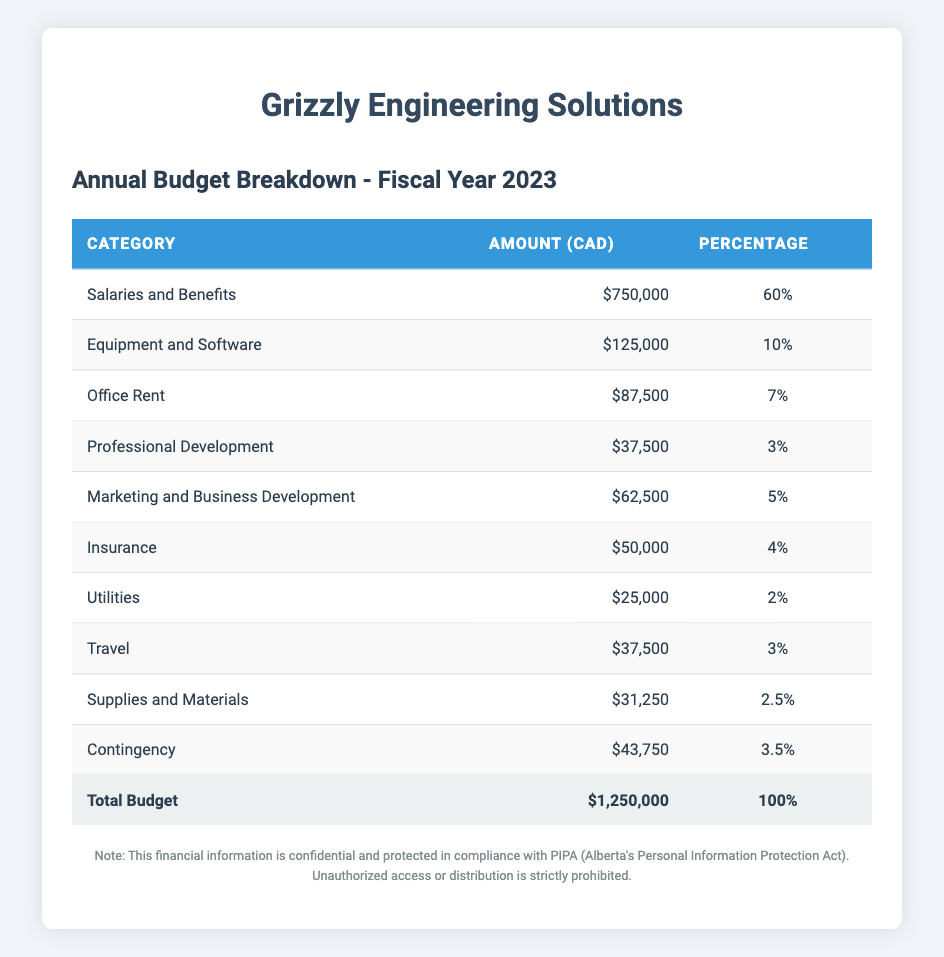What is the total budget for the fiscal year 2023? The total budget listed in the table is presented at the bottom of the budget breakdown, under the "Total Budget" row. It clearly states the amount is 1,250,000 CAD.
Answer: 1,250,000 CAD How much is allocated for Salaries and Benefits? The table indicates that the amount allocated for Salaries and Benefits is shown in its respective row as 750,000 CAD.
Answer: 750,000 CAD What percentage of the total budget is spent on Office Rent? The table shows that Office Rent is allocated 87,500 CAD, and it also states that this amount represents 7% of the total budget. This can be directly retrieved from the table.
Answer: 7% What is the total amount spent on Marketing and Business Development and Office Rent combined? From the table, Marketing and Business Development is 62,500 CAD and Office Rent is 87,500 CAD. Adding these two amounts together: 62,500 + 87,500 = 150,000 CAD.
Answer: 150,000 CAD Is the amount spent on Insurance greater than the amount spent on Utilities? Looking at the table, Insurance is allocated 50,000 CAD, while Utilities is 25,000 CAD. Since 50,000 is greater than 25,000, the statement is true.
Answer: Yes What percentage of the total budget is allocated to Professional Development compared to Equipment and Software? Professional Development is allocated 3% of the total budget (37,500 CAD) and Equipment and Software is 10% (125,000 CAD). To find the ratio, divide 3% by 10%, which is 0.3:1. Therefore, Professional Development receives 30% of what Equipment and Software receives.
Answer: 30% What is the difference in budget allocation between Supplies and Materials and Travel? According to the table, Supplies and Materials is allocated 31,250 CAD and Travel is 37,500 CAD. The difference is calculated as 37,500 - 31,250 = 6,250 CAD.
Answer: 6,250 CAD How much budget percentage is allocated to the contingency fund? The table states that the Contingency category has an allocation of 43,750 CAD, which represents 3.5% of the total budget. This can be checked directly from the relevant row in the table.
Answer: 3.5% What is the average budget allocation across all categories? To calculate the average, first sum all allocations: (750,000 + 125,000 + 87,500 + 37,500 + 62,500 + 50,000 + 25,000 + 37,500 + 31,250 + 43,750 = 1,250,000 CAD), then divide by the number of categories (10): 1,250,000 / 10 = 125,000 CAD.
Answer: 125,000 CAD 